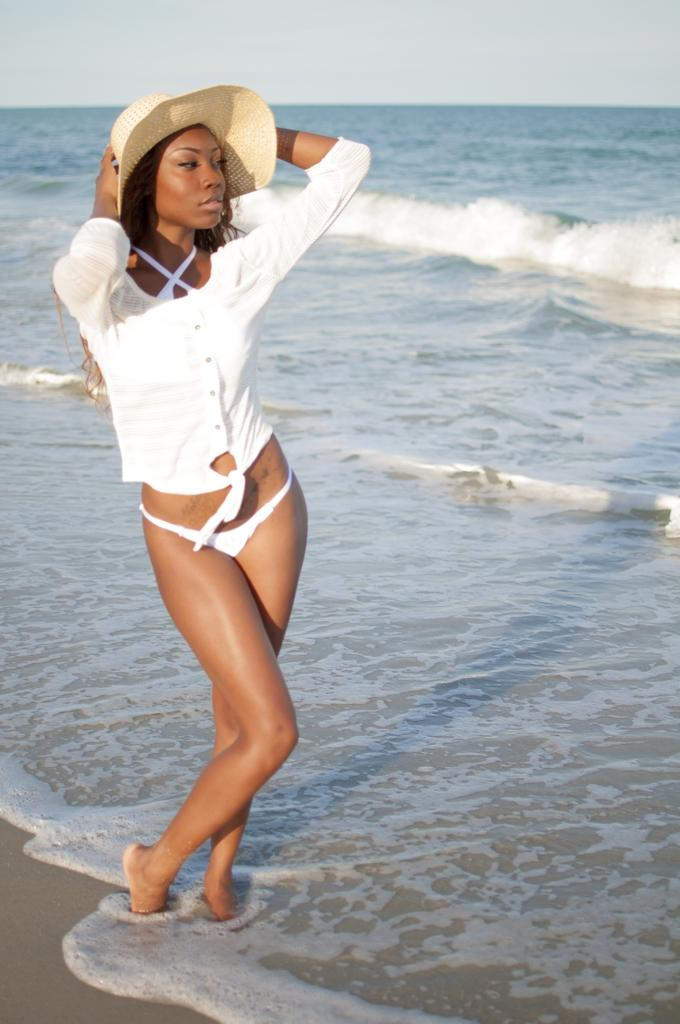Who is present in the image? There is a person in the image. Where is the person located? The person is on the beach. What is the person wearing? The person is wearing clothes and a hat. What can be seen at the top of the image? There is a sky visible at the top of the image. What type of fowl can be seen flying in the image? There is no fowl visible in the image; it only features a person on the beach. 